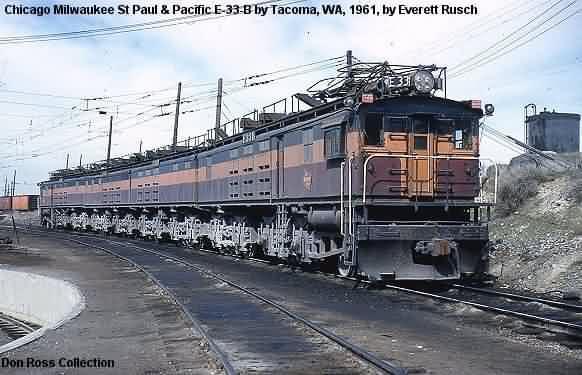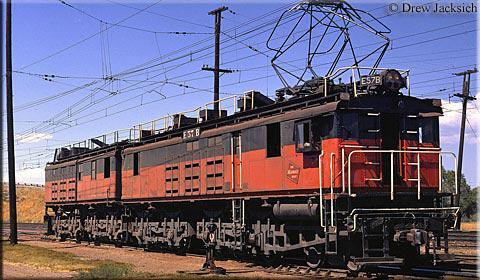The first image is the image on the left, the second image is the image on the right. Assess this claim about the two images: "There is a yellow train with red markings in one of the images.". Correct or not? Answer yes or no. No. The first image is the image on the left, the second image is the image on the right. For the images displayed, is the sentence "An image shows a rightward angled orange and black train, with no bridge extending over it." factually correct? Answer yes or no. Yes. 